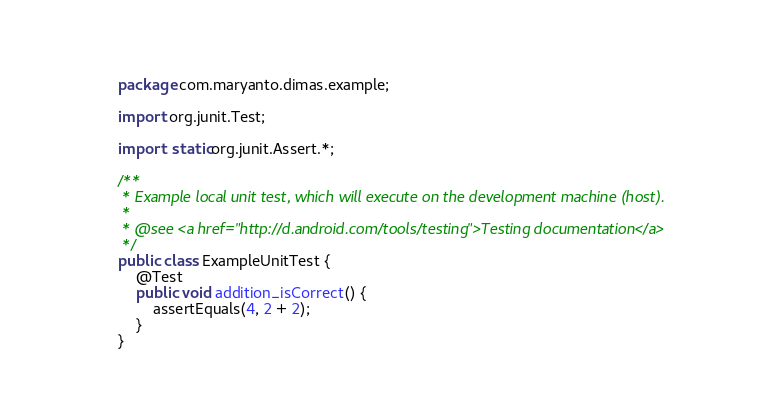Convert code to text. <code><loc_0><loc_0><loc_500><loc_500><_Java_>package com.maryanto.dimas.example;

import org.junit.Test;

import static org.junit.Assert.*;

/**
 * Example local unit test, which will execute on the development machine (host).
 *
 * @see <a href="http://d.android.com/tools/testing">Testing documentation</a>
 */
public class ExampleUnitTest {
    @Test
    public void addition_isCorrect() {
        assertEquals(4, 2 + 2);
    }
}</code> 